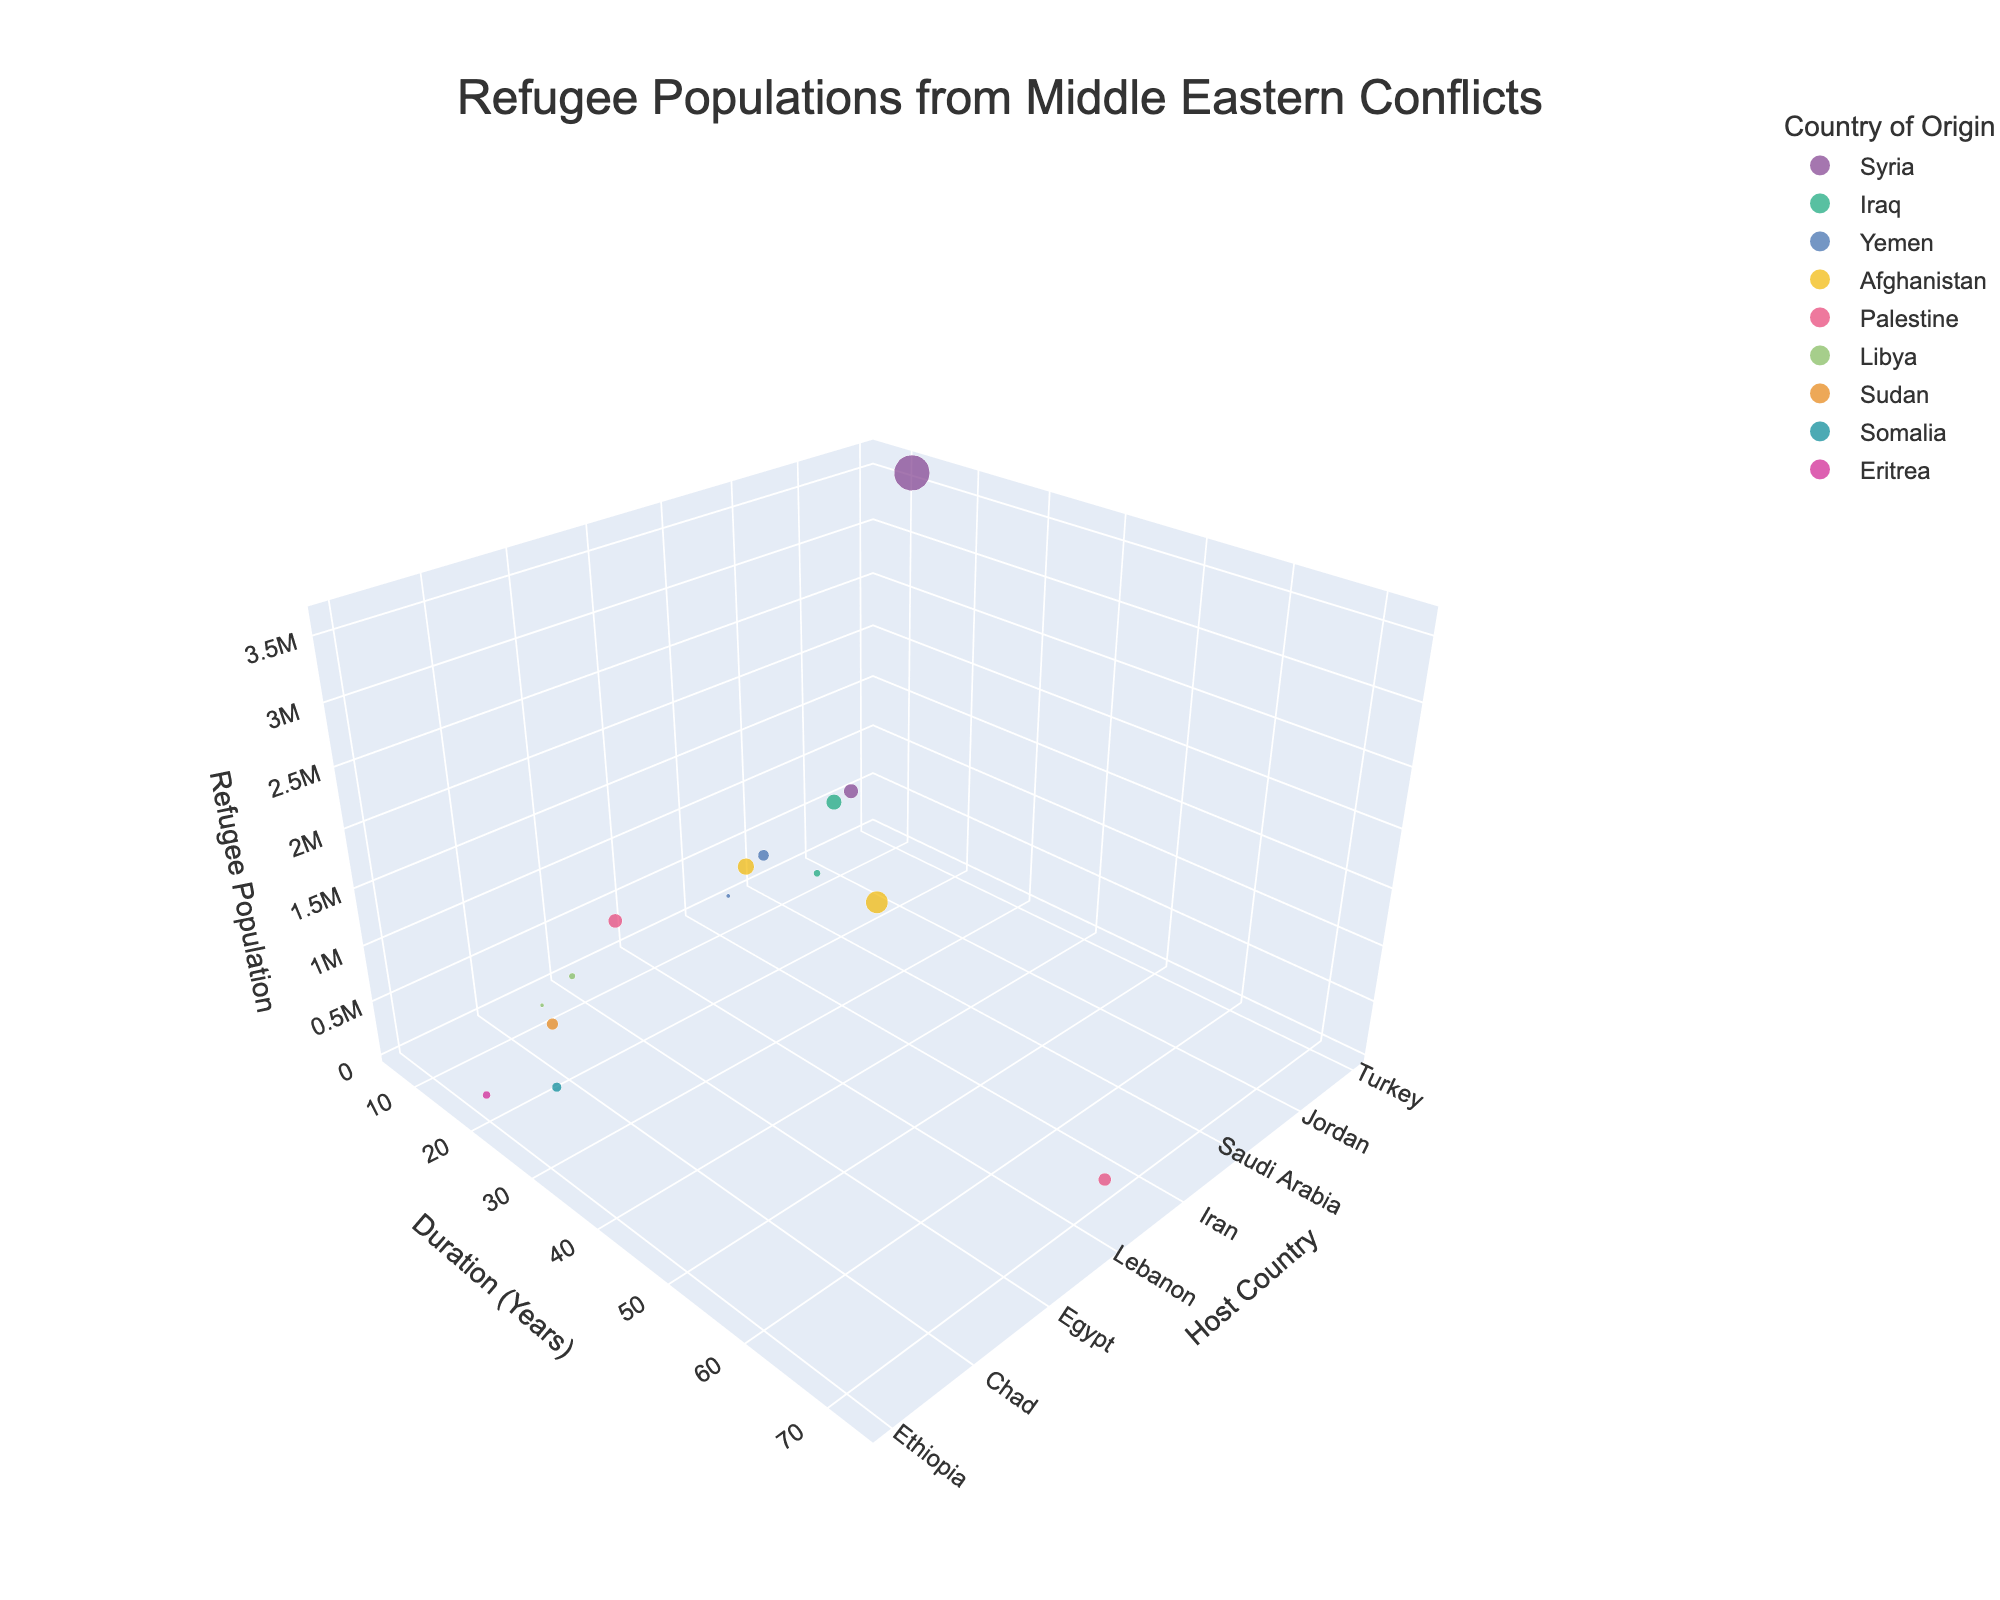How many countries of origin are represented in the figure? Count the unique countries of origin in the figure's legend and hover data.
Answer: 10 Which host country has the largest refugee population from a single country of origin? Look for the largest bubble on the z-axis (Refugee Population) and identify its host country.
Answer: Turkey What is the average duration of displacement for refugees from Afghanistan? Find the bubbles related to Afghanistan, then calculate the average of the y-axis values for these bubbles. (15 + 40) / 2 = 27.5
Answer: 27.5 years Which host countries have refugees from Iraq? Find the bubbles related to Iraq in the figure, noting the host countries.
Answer: Jordan, Sweden Among Syria, Iraq, and Yemen, which country has the longest average duration of displacement for its refugees? Calculate the average duration for each: Syria (12+7)/2 = 9.5, Iraq (9+11)/2 = 10, Yemen (6+7)/2 = 6.5. Compare these values.
Answer: Iraq What is the duration range of displacement for Palestine's refugees? Identify the minimum and maximum y-axis values for Palestine's bubbles.
Answer: 10 - 73 years How does the refugee population in Germany from Syria compare to those in Turkey from Syria? Compare the sizes of the bubbles for Syria's refugees in Germany and Turkey on the z-axis.
Answer: 590,000 vs. 3,600,000 Which country of origin has the single longest duration of displacement? Identify the bubble with the highest y-axis value and note its country of origin.
Answer: Palestine What is the total refugee population from Afghanistan across all host countries? Sum the z-axis values for Afghanistan's bubbles. 780,000 + 1,400,000 = 2,180,000
Answer: 2,180,000 Are there more bubbles representing host countries or countries of origin? Count the unique instances for both host countries and countries of origin in the figure.
Answer: Host countries 